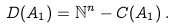Convert formula to latex. <formula><loc_0><loc_0><loc_500><loc_500>D ( A _ { 1 } ) = \mathbb { N } ^ { n } - C ( A _ { 1 } ) \, .</formula> 